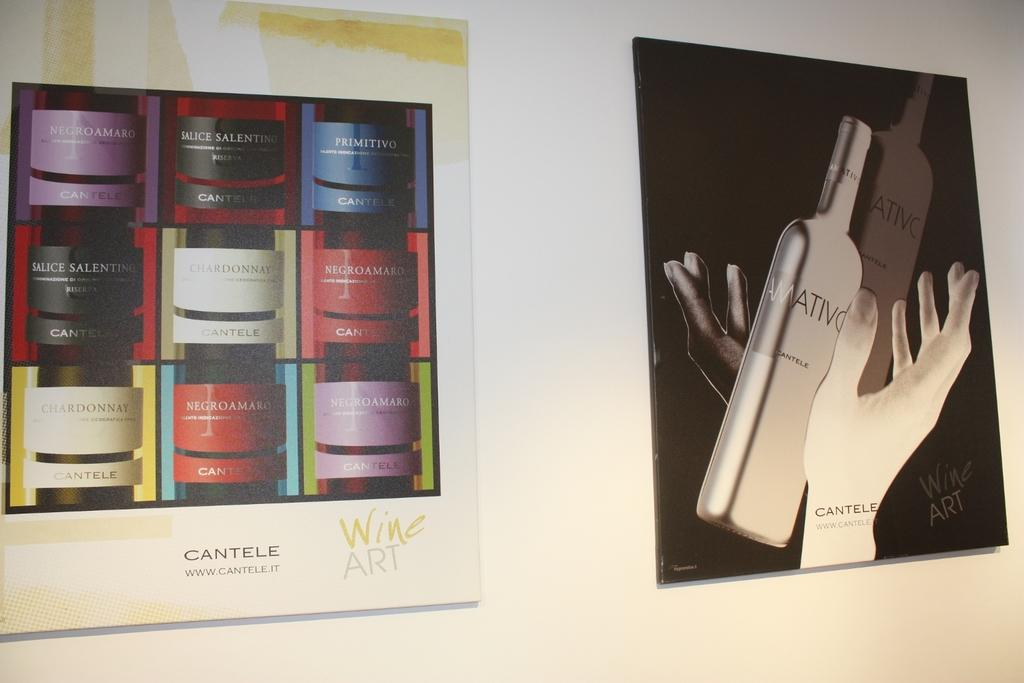<image>
Relay a brief, clear account of the picture shown. Two pictures, one of which has the word Cantele written under it. 